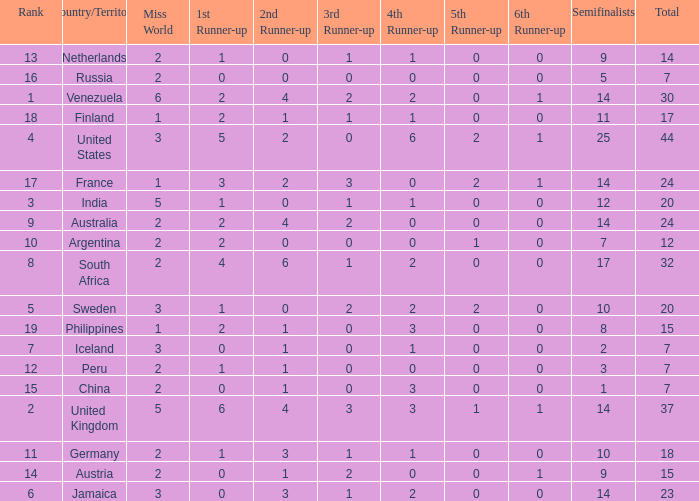What is Venezuela's total rank? 30.0. Would you mind parsing the complete table? {'header': ['Rank', 'Country/Territory', 'Miss World', '1st Runner-up', '2nd Runner-up', '3rd Runner-up', '4th Runner-up', '5th Runner-up', '6th Runner-up', 'Semifinalists', 'Total'], 'rows': [['13', 'Netherlands', '2', '1', '0', '1', '1', '0', '0', '9', '14'], ['16', 'Russia', '2', '0', '0', '0', '0', '0', '0', '5', '7'], ['1', 'Venezuela', '6', '2', '4', '2', '2', '0', '1', '14', '30'], ['18', 'Finland', '1', '2', '1', '1', '1', '0', '0', '11', '17'], ['4', 'United States', '3', '5', '2', '0', '6', '2', '1', '25', '44'], ['17', 'France', '1', '3', '2', '3', '0', '2', '1', '14', '24'], ['3', 'India', '5', '1', '0', '1', '1', '0', '0', '12', '20'], ['9', 'Australia', '2', '2', '4', '2', '0', '0', '0', '14', '24'], ['10', 'Argentina', '2', '2', '0', '0', '0', '1', '0', '7', '12'], ['8', 'South Africa', '2', '4', '6', '1', '2', '0', '0', '17', '32'], ['5', 'Sweden', '3', '1', '0', '2', '2', '2', '0', '10', '20'], ['19', 'Philippines', '1', '2', '1', '0', '3', '0', '0', '8', '15'], ['7', 'Iceland', '3', '0', '1', '0', '1', '0', '0', '2', '7'], ['12', 'Peru', '2', '1', '1', '0', '0', '0', '0', '3', '7'], ['15', 'China', '2', '0', '1', '0', '3', '0', '0', '1', '7'], ['2', 'United Kingdom', '5', '6', '4', '3', '3', '1', '1', '14', '37'], ['11', 'Germany', '2', '1', '3', '1', '1', '0', '0', '10', '18'], ['14', 'Austria', '2', '0', '1', '2', '0', '0', '1', '9', '15'], ['6', 'Jamaica', '3', '0', '3', '1', '2', '0', '0', '14', '23']]} 